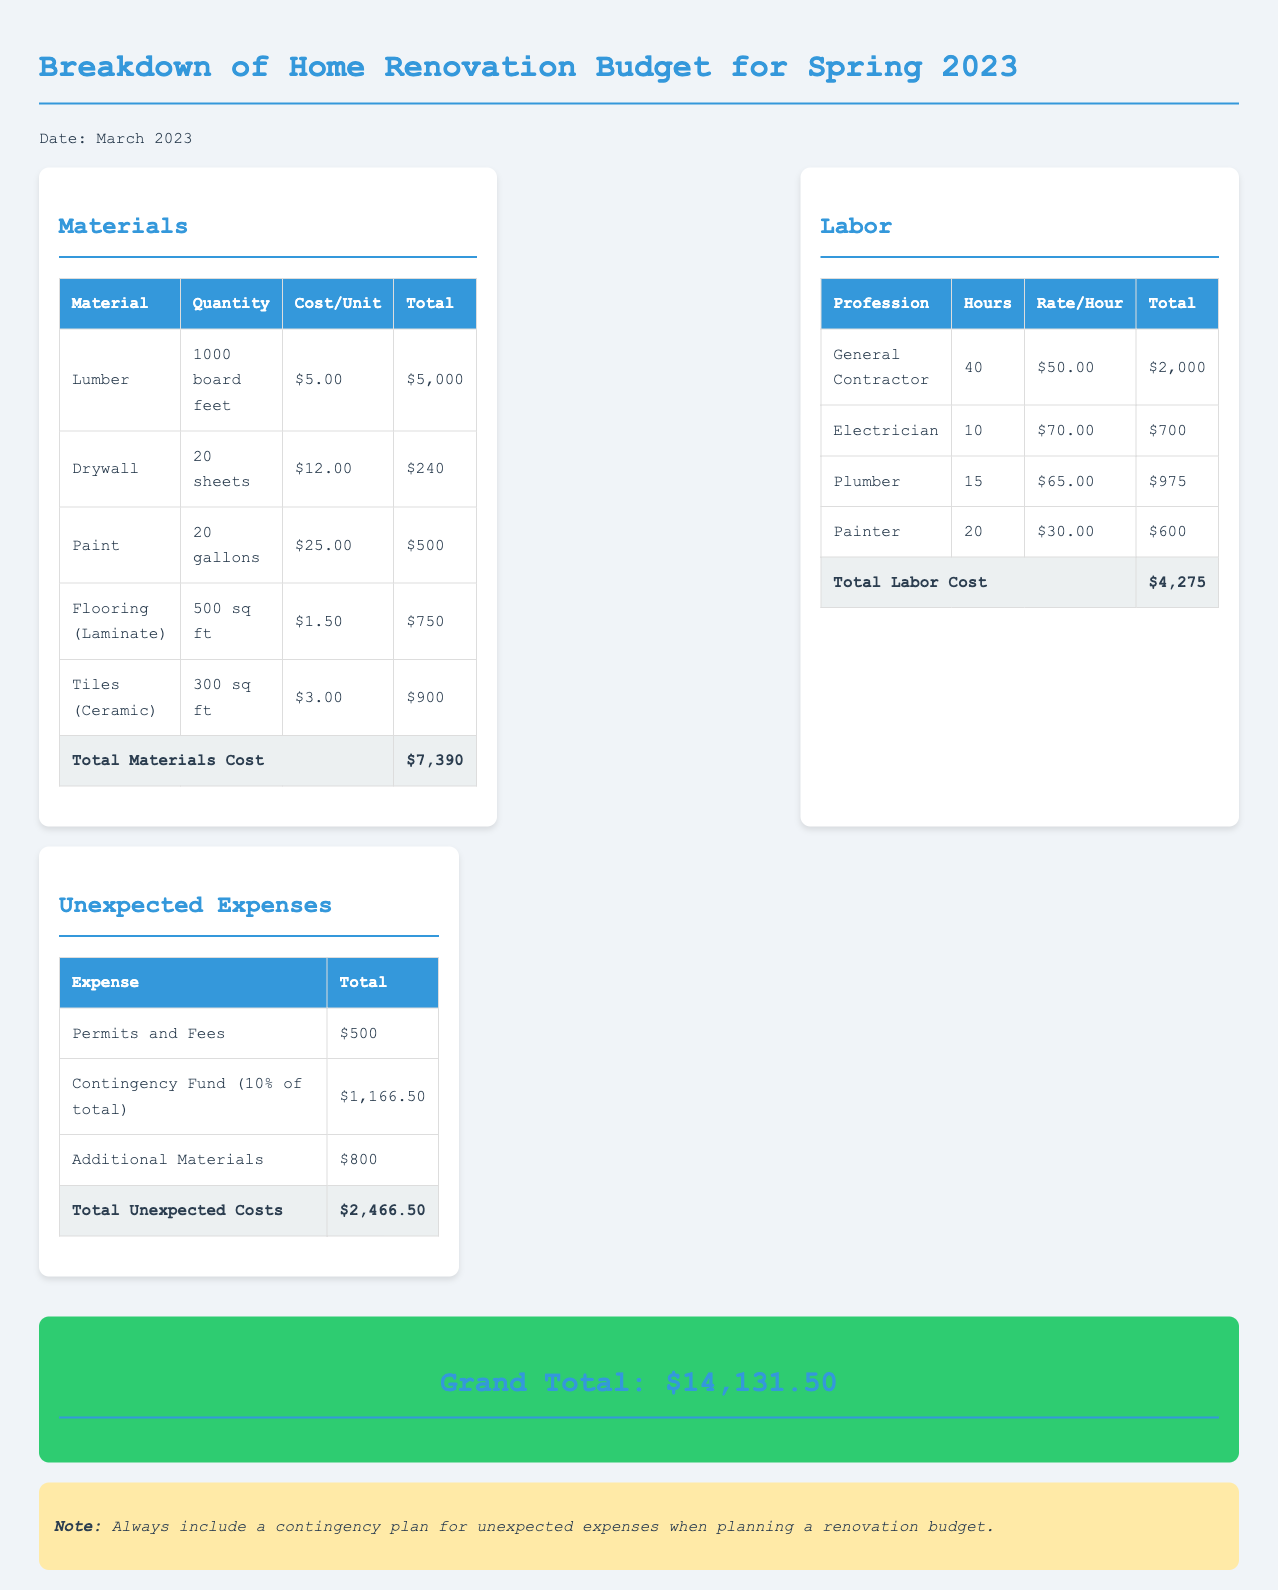what is the total cost for materials? The total cost for materials is summarized in the materials table, which gives a total of $7,390.
Answer: $7,390 what is the hourly rate for the electrician? The hourly rate for the electrician can be found in the labor section, which states it is $70.00.
Answer: $70.00 how many gallons of paint were purchased? The quantity of paint is detailed in the materials table, indicating that 20 gallons were purchased.
Answer: 20 gallons what is the total unexpected cost? The total unexpected cost is provided at the end of the unexpected expenses section, totaling $2,466.50.
Answer: $2,466.50 who is the general contractor? The document lists the general contractor as one of the labor professions but does not specify a name, indicating it's a title rather than a specific individual.
Answer: General Contractor what percentage of the total budget is set aside for the contingency fund? The contingency fund is noted as being 10% of the total budget in the unexpected expenses section.
Answer: 10% what was the cost of drywall? The cost of drywall is detailed in the materials table, showing it to be $240.
Answer: $240 how many total hours were worked by the plumber? The total hours worked by the plumber are found in the labor table, which shows 15 hours.
Answer: 15 hours what is the grand total for the renovation budget? The grand total is summarized in the document as $14,131.50 at the bottom of the budget breakdown.
Answer: $14,131.50 